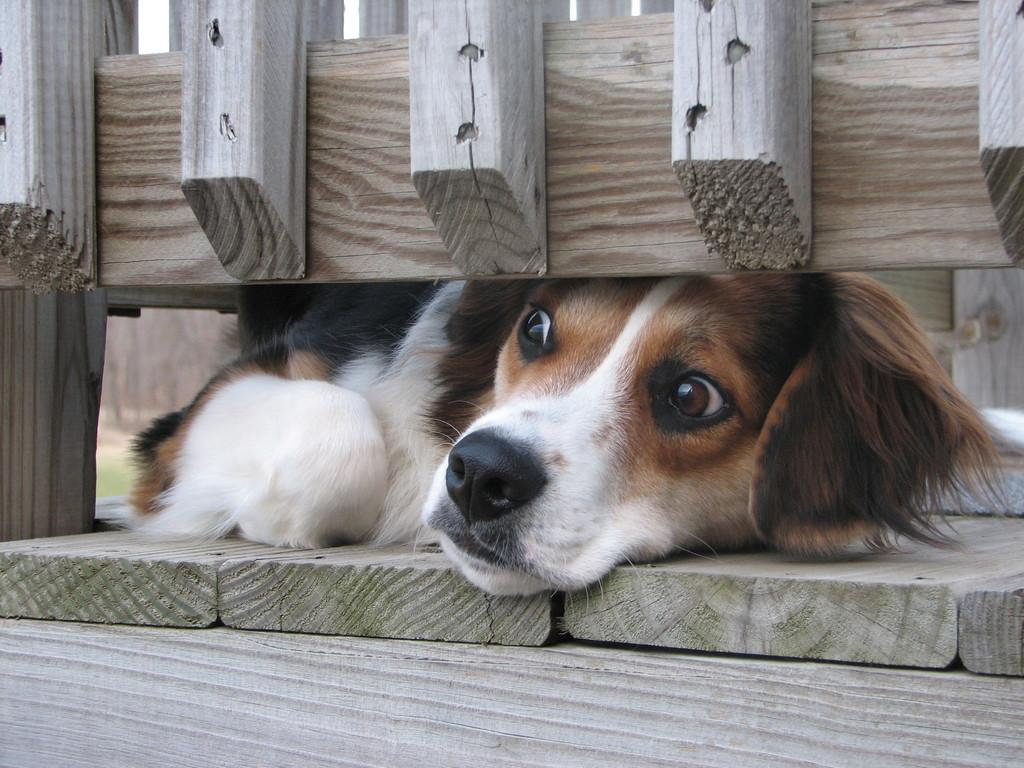What animal can be seen in the image? There is a dog in the image. What is the dog lying on? The dog is lying on a wooden surface. What type of structure is visible in the foreground of the image? There is a wooden railing in the foreground of the image. What type of breakfast is the dog eating in the image? There is no breakfast present in the image; the dog is simply lying on a wooden surface. 